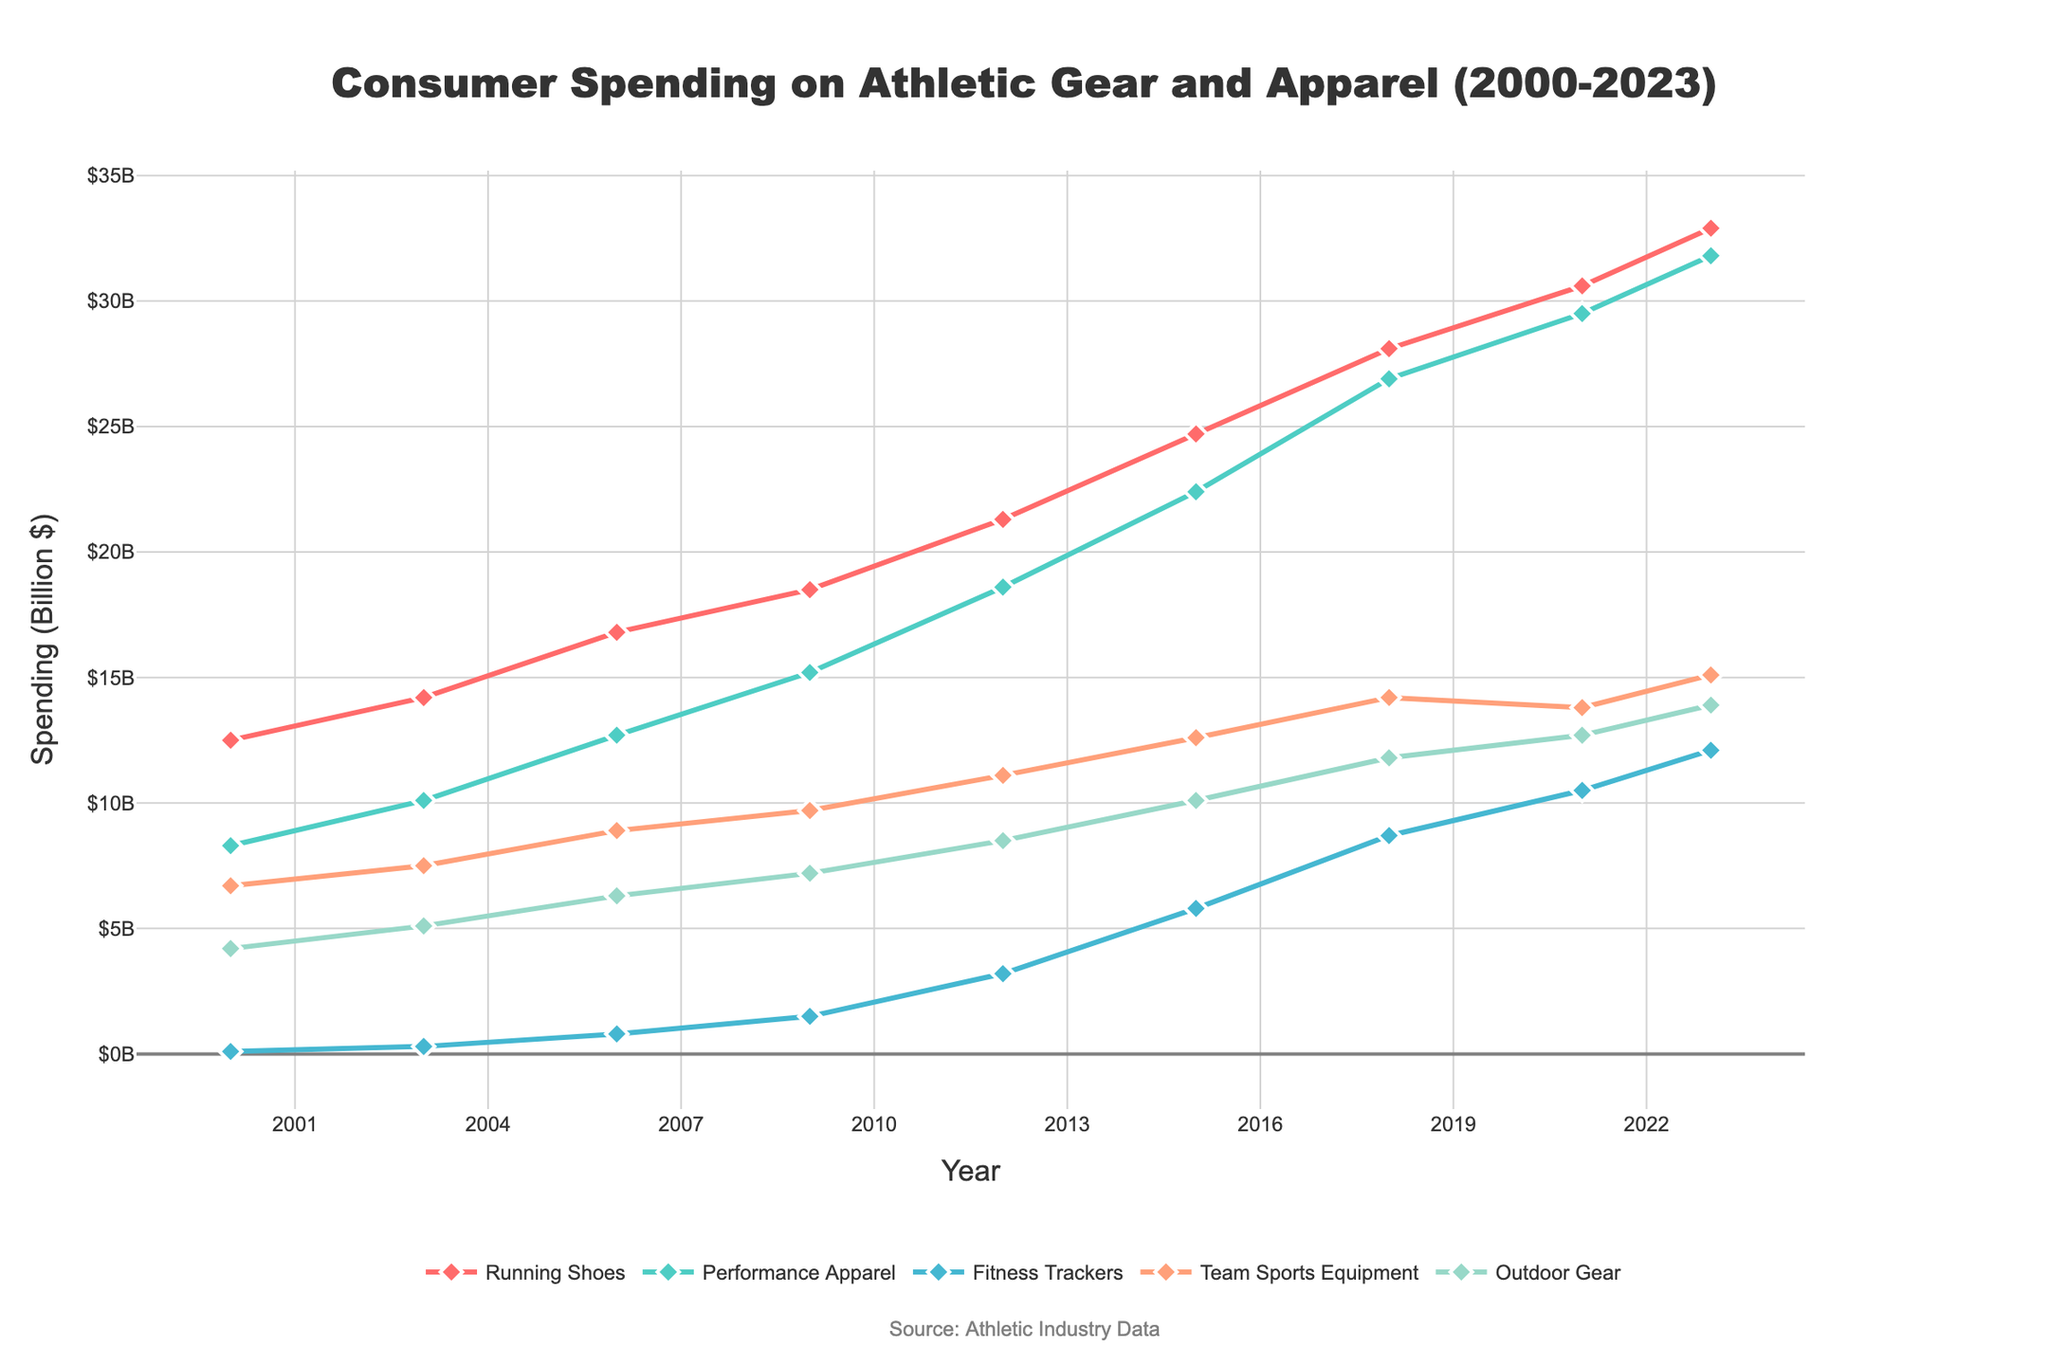How has consumer spending on Running Shoes changed from 2000 to 2023? The graph shows the spending on Running Shoes in 2000 and 2023. In 2000, the spending was $12.5 billion, and in 2023, it was $32.9 billion. To see the change, subtract the 2000 value from the 2023 value: 32.9 - 12.5 = 20.4
Answer: $20.4 billion What trend can you observe in Performance Apparel spending from 2000 to 2023? Observing the graph for Performance Apparel, spending consistently increased from $8.3 billion in 2000 to $31.8 billion in 2023, showing a steady upward trend.
Answer: Consistent increase What is the difference in spending between Fitness Trackers and Team Sports Equipment in 2023? For 2023, the graph shows that spending on Fitness Trackers is $12.1 billion and on Team Sports Equipment is $15.1 billion. The difference is 15.1 - 12.1 = 3.0
Answer: $3.0 billion Which product type experienced the highest growth rate in consumer spending between 2000 and 2023? To find the highest growth rate, calculate the growth for each product type from 2000 to 2023. Running Shoes: (32.9-12.5)/12.5 = 1.632, Performance Apparel: (31.8-8.3)/8.3 = 2.831, Fitness Trackers: (12.1-0.1)/0.1 = 120, Team Sports Equipment: (15.1-6.7)/6.7 = 1.253, Outdoor Gear: (13.9-4.2)/4.2 = 2.310. Fitness Trackers have the highest growth rate of 120.
Answer: Fitness Trackers Which product type showed the least variability in spending from 2000 to 2023? Variability can be assessed by observing fluctuations in the plotted lines. Running Shoes, Performance Apparel, Team Sports Equipment, and Outdoor Gear show consistent but varying upward trends. Fitness Trackers had the lowest initial value and a significant spike but consistent rise post-2009. Team Sports Equipment shows the smallest differences between points, indicating the least variability.
Answer: Team Sports Equipment Considering 2015 data, which product type had the second-highest consumer spending? For 2015, the graph shows consumer spending for various products. Running Shoes ($24.7 billion) and Performance Apparel ($22.4 billion) were the highest. As $24.7 billion (Running Shoes) is the highest, the second-highest is $22.4 billion (Performance Apparel).
Answer: Performance Apparel What has been the average annual increase in spending on Outdoor Gear from 2000 to 2023? The spending on Outdoor Gear in 2000 was $4.2 billion and $13.9 billion in 2023. To find the average annual increase, subtract the 2000 value from the 2023 value and divide by the number of years: (13.9 - 4.2) / (2023 - 2000) = 9.7 / 23 = 0.4217.
Answer: $0.42 billion Compare the consumer spending on Fitness Trackers and Running Shoes in 2006. Which was higher and by how much? In 2006, Fitness Trackers spending was $0.8 billion, while Running Shoes was $16.8 billion. The difference is 16.8 - 0.8 = 16
Answer: Running Shoes by $16 billion How much did the consumer spending on Performance Apparel and Outdoor Gear combined grow from 2012 to 2021? In 2012, spending on Performance Apparel was $18.6 billion and Outdoor Gear was $8.5 billion, summing up to $27.1 billion. In 2021, Performance Apparel was $29.5 billion and Outdoor Gear was $12.7 billion, summing up to $42.2 billion. The combined growth is 42.2 - 27.1 = 15.1
Answer: $15.1 billion 